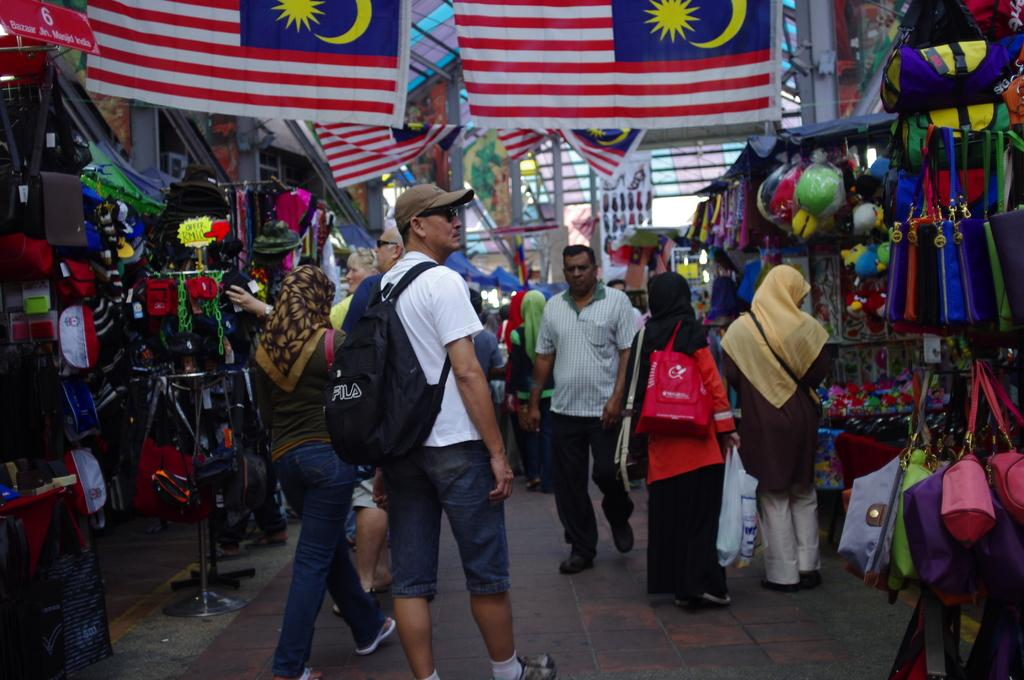What types of people are present in the image? There are men and women standing in the image. What can be seen in the image besides the people? There are flags in the image. What type of appliance is being used by the people in the image? There is no appliance visible in the image; it only shows men, women, and flags. 